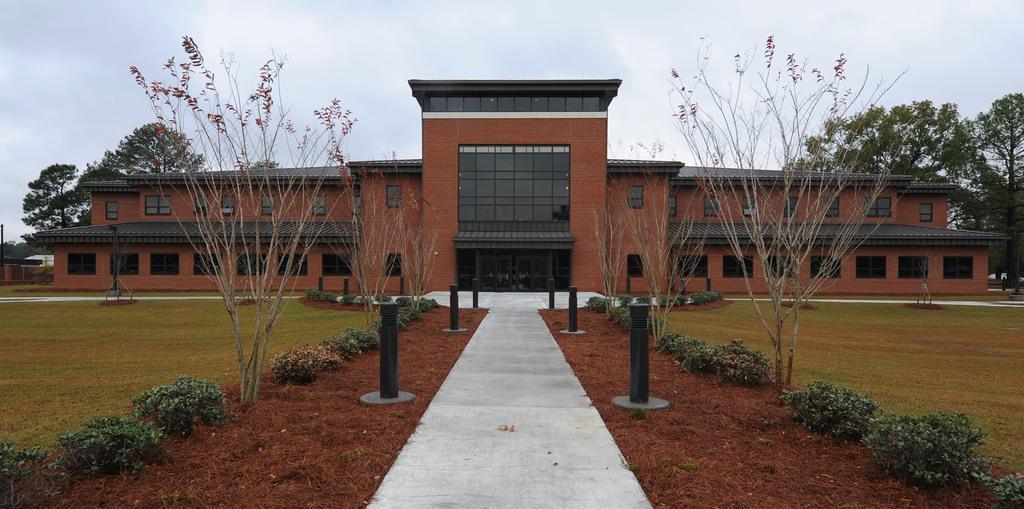Describe this image in one or two sentences. In this image in the center there is a building and some trees and also there are some rods, walkway, mud, plants and grass. On the left side there is one pole, at the top there is sky. 